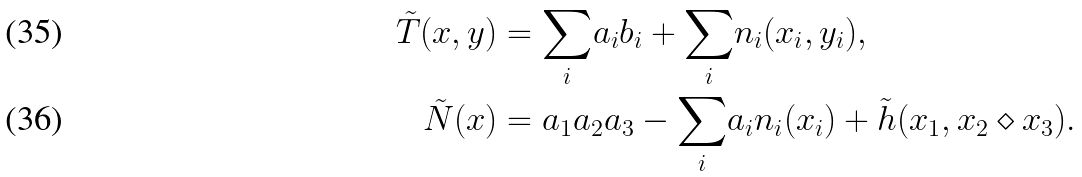Convert formula to latex. <formula><loc_0><loc_0><loc_500><loc_500>\tilde { T } ( x , y ) & = { \sum _ { i } } a _ { i } b _ { i } + { \sum _ { i } } n _ { i } ( x _ { i } , y _ { i } ) , \\ \tilde { N } ( x ) & = a _ { 1 } a _ { 2 } a _ { 3 } - { \sum _ { i } } a _ { i } n _ { i } ( x _ { i } ) + \tilde { h } ( x _ { 1 } , x _ { 2 } \diamond x _ { 3 } ) .</formula> 